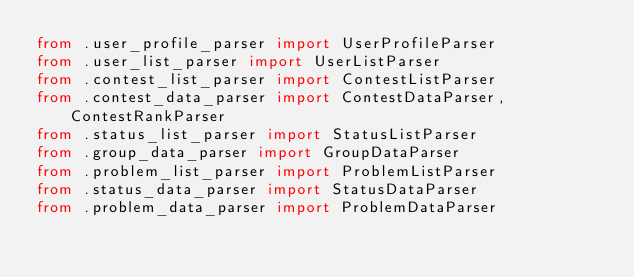Convert code to text. <code><loc_0><loc_0><loc_500><loc_500><_Python_>from .user_profile_parser import UserProfileParser
from .user_list_parser import UserListParser
from .contest_list_parser import ContestListParser
from .contest_data_parser import ContestDataParser, ContestRankParser
from .status_list_parser import StatusListParser
from .group_data_parser import GroupDataParser
from .problem_list_parser import ProblemListParser
from .status_data_parser import StatusDataParser
from .problem_data_parser import ProblemDataParser
</code> 